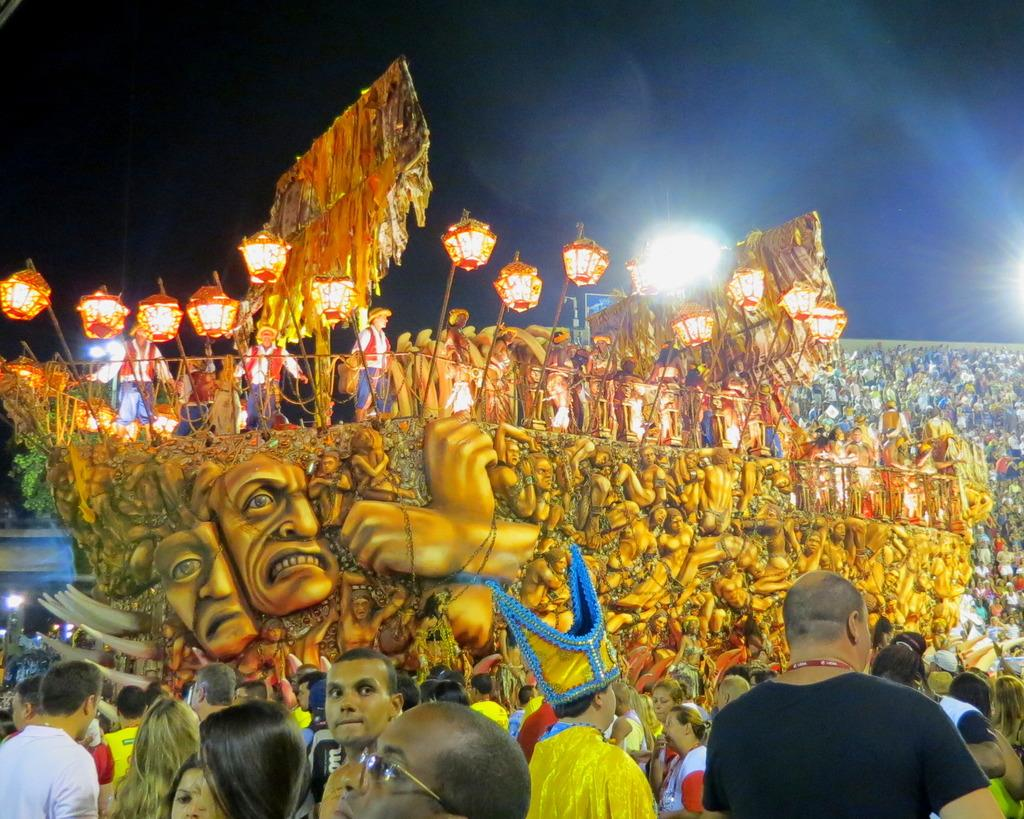What is depicted on the wall in the image? There is a wall with sculptures in the image. Are there any people present in the image? Yes, there are people standing in the image. What type of disgust can be seen on the faces of the people in the image? There is no indication of disgust on the faces of the people in the image. How many snails are crawling on the sculptures in the image? There are no snails present in the image; it features a wall with sculptures and people standing nearby. 